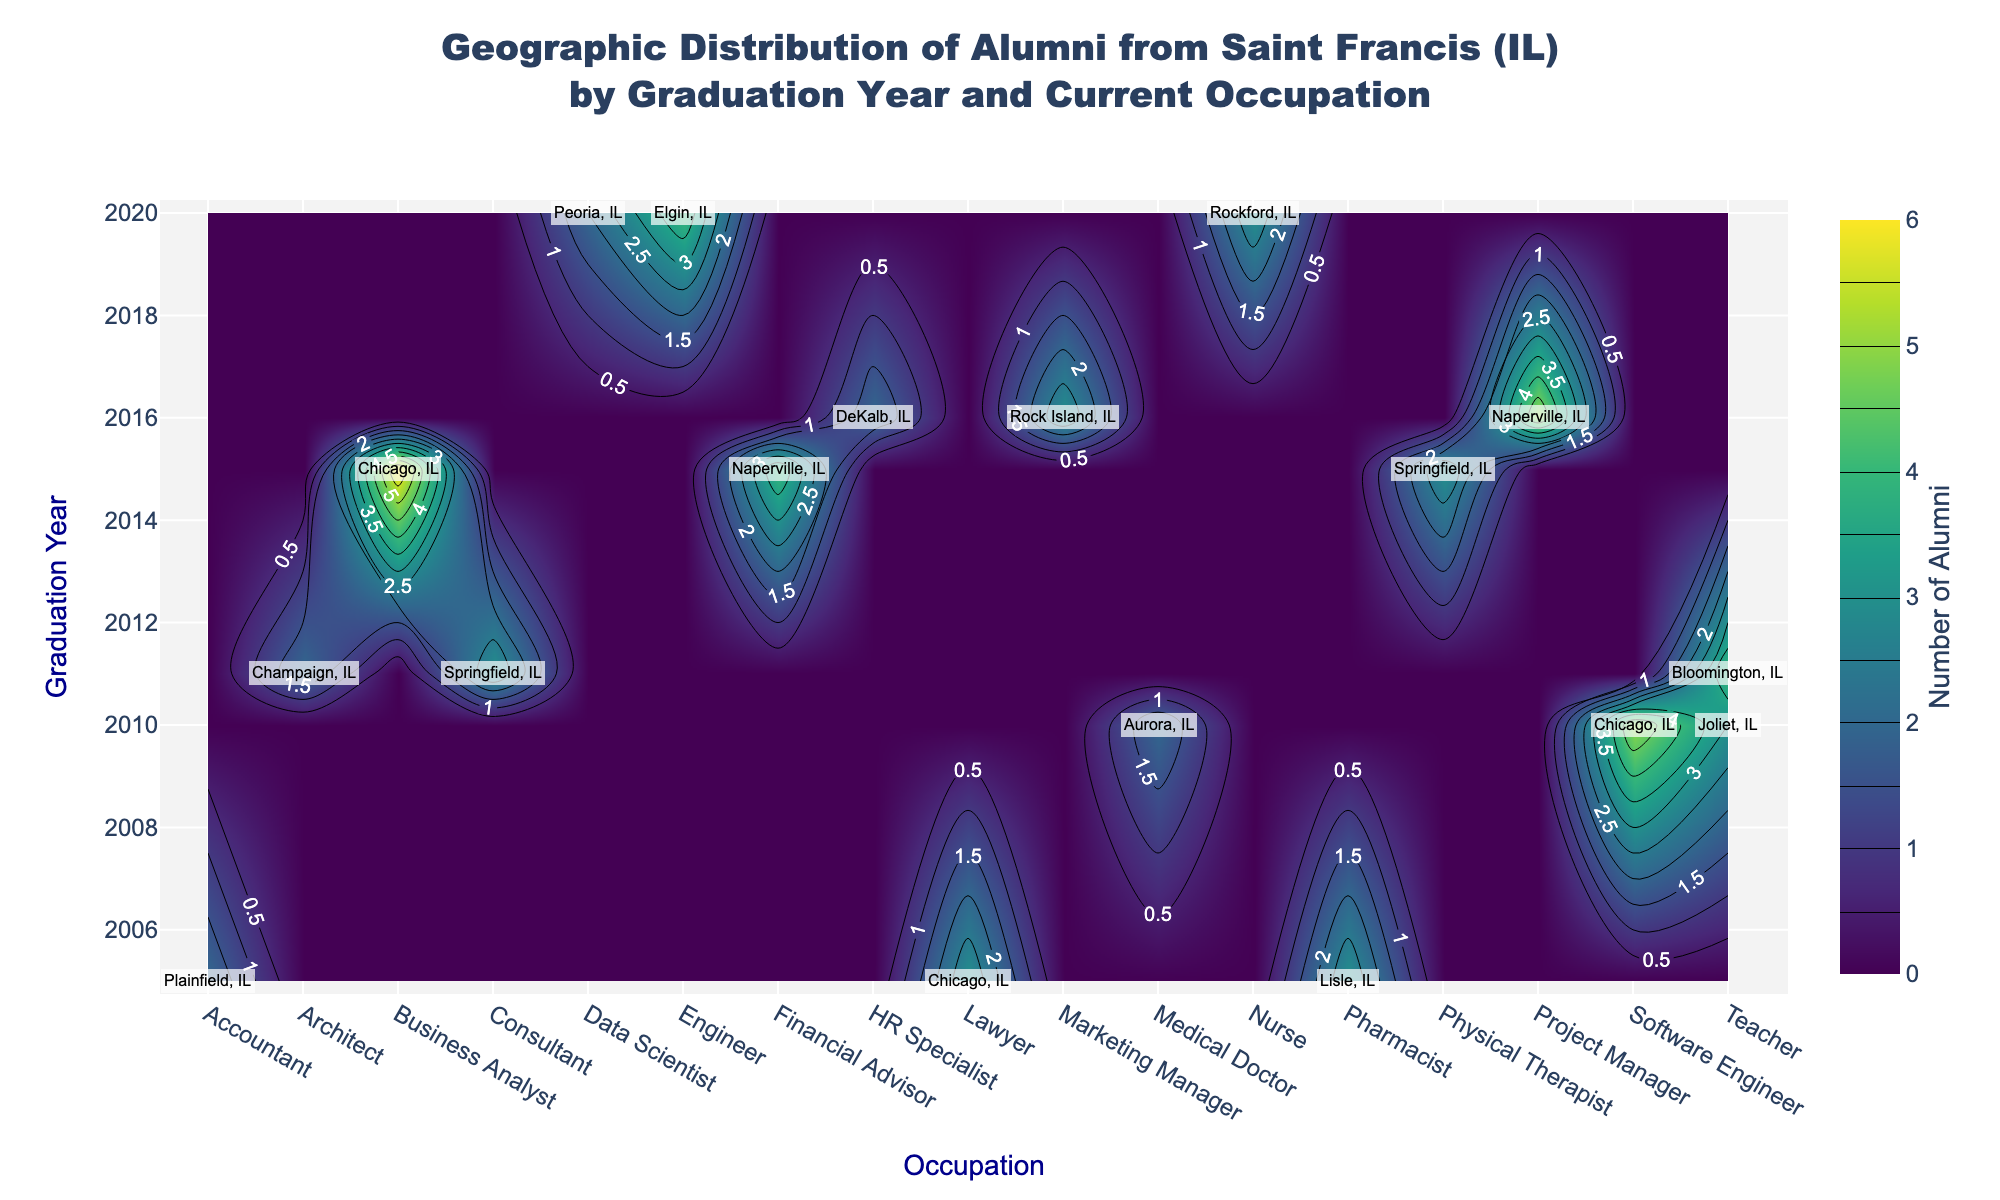What's the color scheme used in the contour plot? The color scheme used in the contour plot can be identified by observing the colors represented in the plot and the colorbar to the right, labeled "Number of Alumni". The color scheme is "Viridis", which progresses from dark blue to green to yellow.
Answer: Viridis What is the data range represented by the colorbar on the right? The data range represented by the colorbar can be determined by looking at the minimum and maximum values shown on the colorbar. The range indicates the number of alumni, from the lowest value of zero to the highest number seen.
Answer: 0 to 6 Which occupation had the highest number of alumni in 2015? To find the occupation with the highest number of alumni in 2015, locate the 2015 graduation year on the y-axis, then find the occupation with the peak value within the 2015 row on the contour plot. The tallest peak in this row corresponds to "Business Analyst".
Answer: Business Analyst What occupations are labeled for alumni who graduated in 2020? For the graduation year 2020, move horizontally across the plot to see which occupations have labeled cities and states. The occupations with labels are "Data Scientist," "Nurse," and "Engineer".
Answer: Data Scientist, Nurse, Engineer What is the total number of alumni who graduated in 2005 across all occupations? Sum the number of alumni for each occupation in 2005. From the plot, identify the figures for Lawyer, Accountant, and Pharmacist. The values should be 3, 2, and 3 respectively, summing to a total.
Answer: 8 Compare the number of alumni who became Teachers in 2010 and 2011. Which year had more? Locate the values on the contour plot for Teachers in 2010 and 2011. In 2010, there are 3, and in 2011, there are 4. Comparing these, 2011 had more teachers.
Answer: 2011 Identify the occupation with a significant number of alumni in Springfield, IL across two different graduation years. Look for annotations that include Springfield, IL. In 2015, there were Physical Therapists, and in 2011, there were Consultants, discerned from the contour peaks labeled for those occupations. Both have three alumni.
Answer: Physical Therapist, Consultant Which graduation year saw the greatest variety of different occupations according to the contour plot? Evaluate each year on the y-axis to determine which year has the greatest number of peaks spread across different occupations. By observing the pattern, 2016 seems to have multiple high points in various occupations like Project Manager, Marketing Manager, and HR Specialist.
Answer: 2016 Was there any year with no alumni becoming a Medical Doctor? Check each graduation year and observe if there are any peaks labeled "Medical Doctor.” There are contour peaks indicating Medical Doctors only for the year 2010, suggesting no other years had alumni with this occupation.
Answer: Yes What's the occupation of alumni from 2016 relocating to Naperville, IL? Locate the graduation year 2016 and observe the labeled annotations in the contour plot. Naperville, IL, in 2016 is labeled for the occupation of "Project Manager".
Answer: Project Manager 